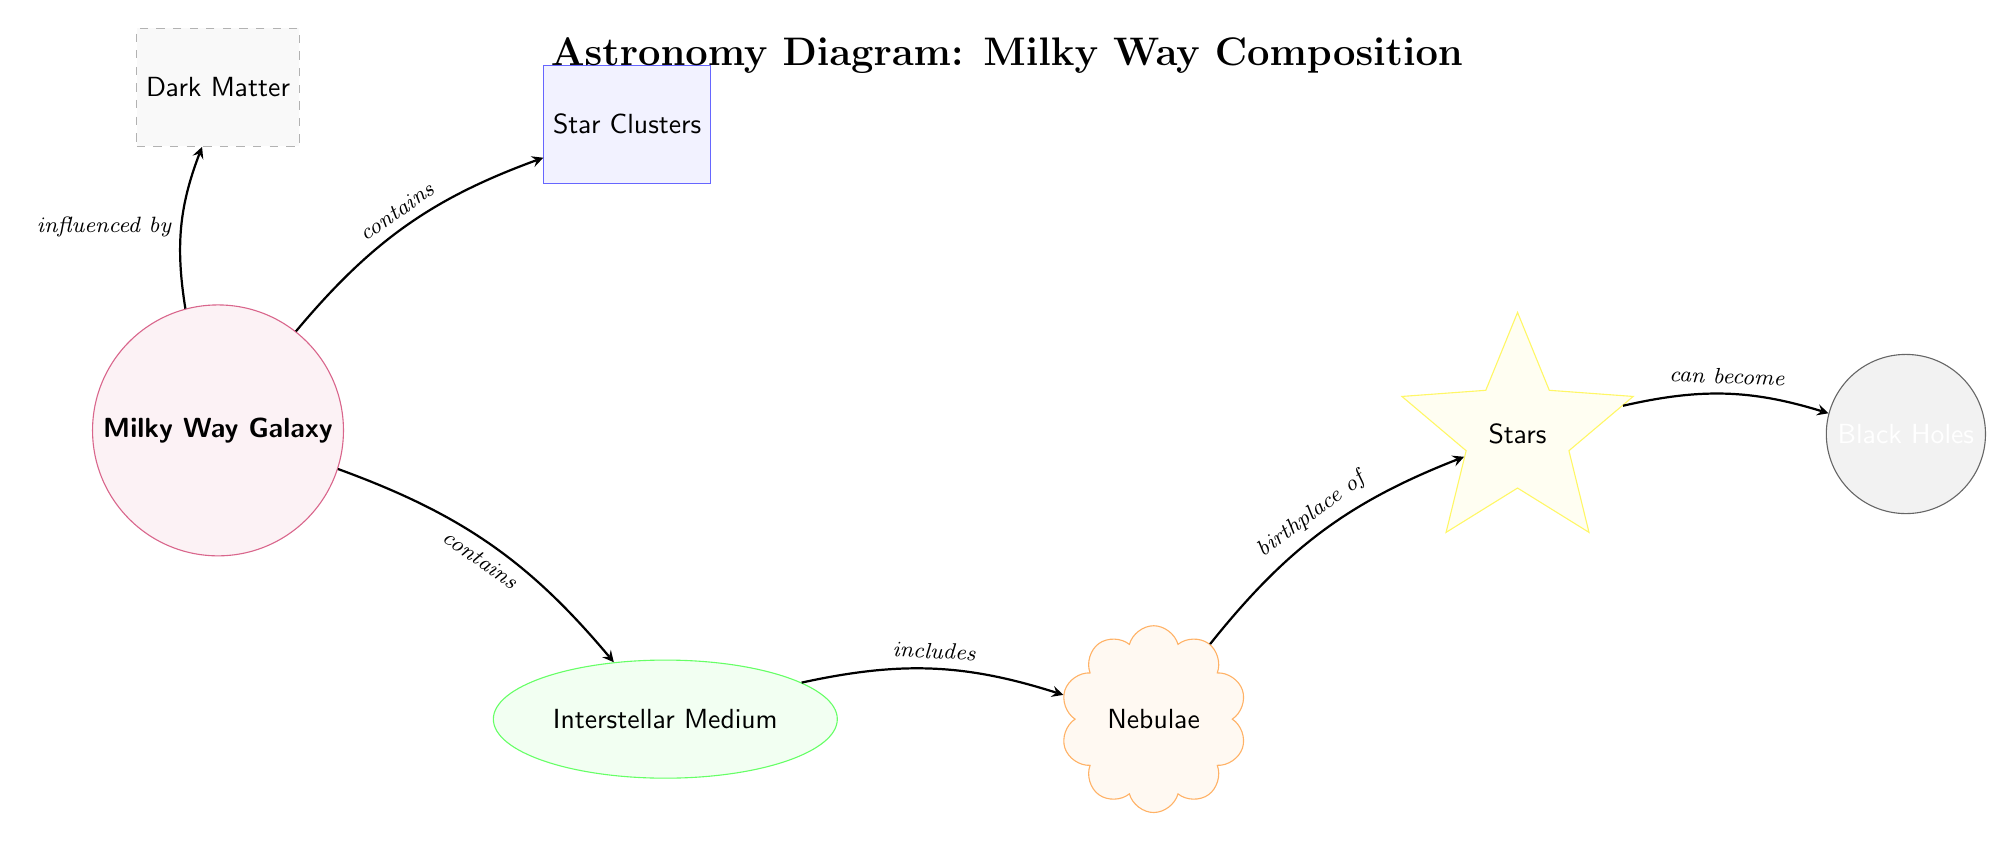What is at the center of the Milky Way diagram? The diagram specifically identifies the Milky Way Galaxy as being at the center, indicated by the node labeled "Milky Way Galaxy."
Answer: Milky Way Galaxy How many stellar bodies are identified in the diagram? The diagram lists only one type of stellar body labeled as "Stars," indicating singularity in the category of stellar bodies shown.
Answer: 1 Which component is suggested as the birthplace of stars? The diagram indicates that "Nebulae" is directly connected to "Stars," showing that nebulae are recognized as the birthplace of stars.
Answer: Nebulae What influences the Milky Way Galaxy according to the diagram? The diagram shows an arrow pointing from "Dark Matter" to "Milky Way Galaxy," indicating a relationship where dark matter is said to influence the Milky Way.
Answer: Dark Matter What can stars become according to this diagram? The diagram connects "Stars" to "Black Holes" with an arrow labeled "can become," indicating that stars may transform into black holes.
Answer: Black Holes Which component comes after the interstellar medium in the diagram flow? The diagram shows that after the "Interstellar Medium," there is a connection to "Nebulae," indicating the next component in the flow.
Answer: Nebulae What does the Milky Way Galaxy contain apart from star clusters? The diagram states that the Milky Way contains multiple elements, specifically highlighting "Interstellar Medium" as another component it contains.
Answer: Interstellar Medium What is the shape of star groups in the diagram? The diagram categorizes star clusters with a rectangle shape indicated by the style used at that node, showing the shape signifies a grouping.
Answer: Rectangle How are the components in the diagram connected? The connections between the nodes in the diagram are represented by arrows denoting relationships and flows, indicating the interactions between different components.
Answer: Arrows 